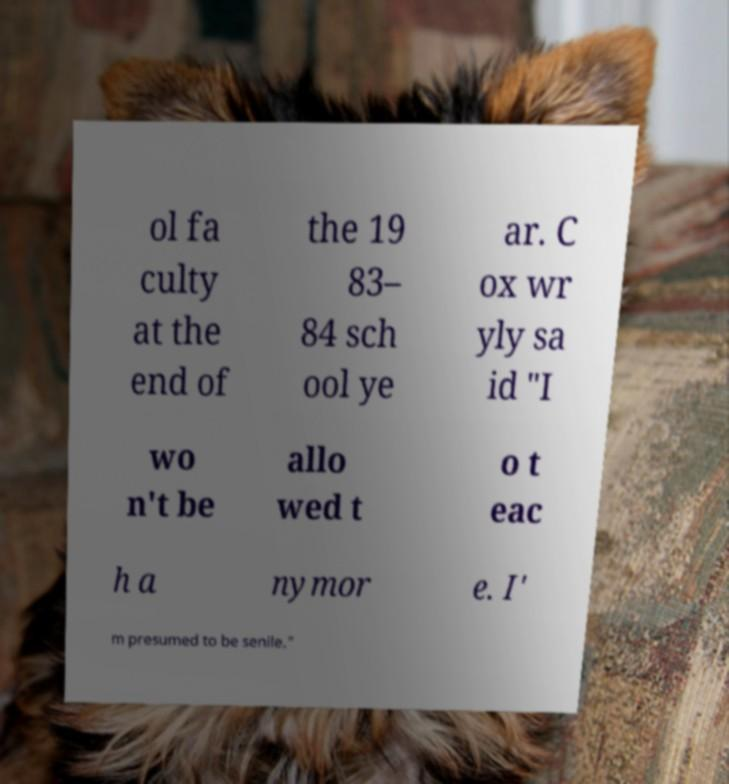Please identify and transcribe the text found in this image. ol fa culty at the end of the 19 83– 84 sch ool ye ar. C ox wr yly sa id "I wo n't be allo wed t o t eac h a nymor e. I' m presumed to be senile." 